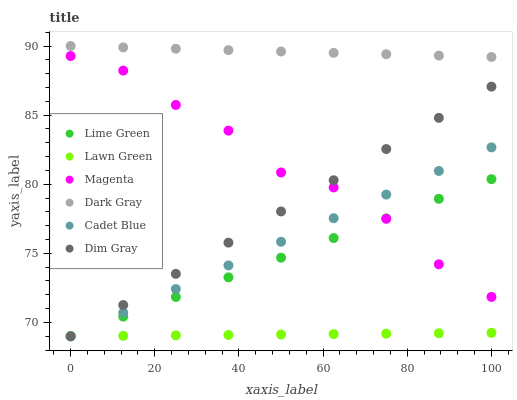Does Lawn Green have the minimum area under the curve?
Answer yes or no. Yes. Does Dark Gray have the maximum area under the curve?
Answer yes or no. Yes. Does Cadet Blue have the minimum area under the curve?
Answer yes or no. No. Does Cadet Blue have the maximum area under the curve?
Answer yes or no. No. Is Cadet Blue the smoothest?
Answer yes or no. Yes. Is Magenta the roughest?
Answer yes or no. Yes. Is Dark Gray the smoothest?
Answer yes or no. No. Is Dark Gray the roughest?
Answer yes or no. No. Does Lawn Green have the lowest value?
Answer yes or no. Yes. Does Dark Gray have the lowest value?
Answer yes or no. No. Does Dark Gray have the highest value?
Answer yes or no. Yes. Does Cadet Blue have the highest value?
Answer yes or no. No. Is Magenta less than Dark Gray?
Answer yes or no. Yes. Is Dark Gray greater than Magenta?
Answer yes or no. Yes. Does Dim Gray intersect Lime Green?
Answer yes or no. Yes. Is Dim Gray less than Lime Green?
Answer yes or no. No. Is Dim Gray greater than Lime Green?
Answer yes or no. No. Does Magenta intersect Dark Gray?
Answer yes or no. No. 